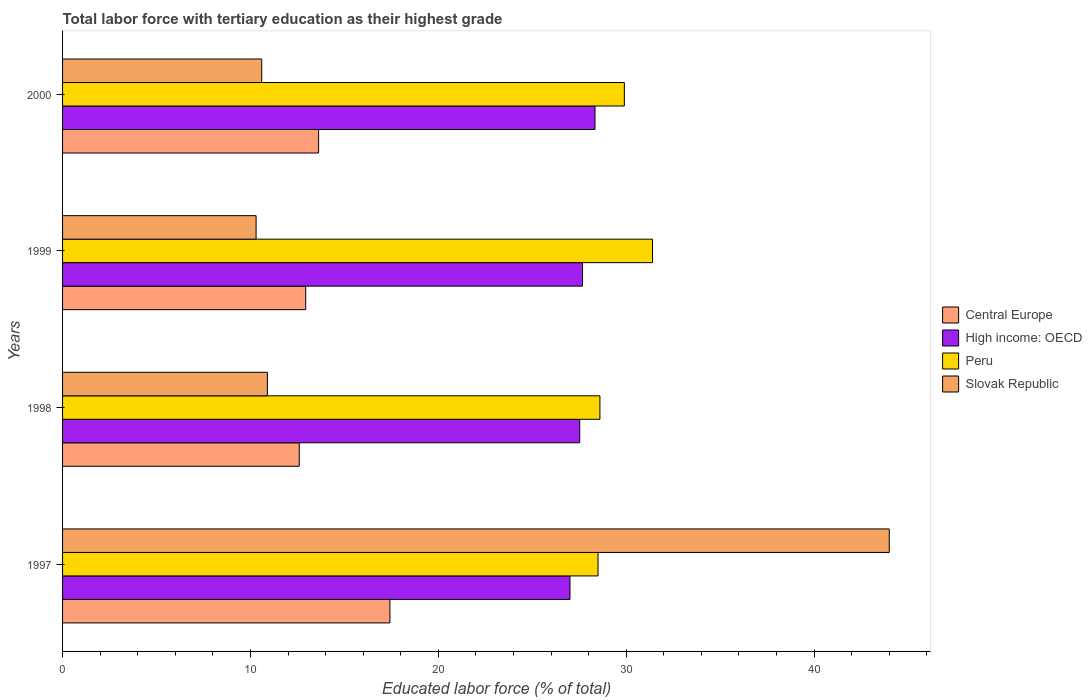How many bars are there on the 1st tick from the top?
Ensure brevity in your answer.  4. In how many cases, is the number of bars for a given year not equal to the number of legend labels?
Your response must be concise. 0. What is the percentage of male labor force with tertiary education in Central Europe in 1998?
Provide a succinct answer. 12.6. Across all years, what is the minimum percentage of male labor force with tertiary education in High income: OECD?
Ensure brevity in your answer.  27.01. In which year was the percentage of male labor force with tertiary education in Peru maximum?
Give a very brief answer. 1999. In which year was the percentage of male labor force with tertiary education in High income: OECD minimum?
Ensure brevity in your answer.  1997. What is the total percentage of male labor force with tertiary education in Central Europe in the graph?
Keep it short and to the point. 56.59. What is the difference between the percentage of male labor force with tertiary education in Peru in 1997 and that in 1999?
Your answer should be compact. -2.9. What is the difference between the percentage of male labor force with tertiary education in Slovak Republic in 2000 and the percentage of male labor force with tertiary education in High income: OECD in 1997?
Offer a very short reply. -16.41. What is the average percentage of male labor force with tertiary education in High income: OECD per year?
Ensure brevity in your answer.  27.64. In the year 1999, what is the difference between the percentage of male labor force with tertiary education in Peru and percentage of male labor force with tertiary education in Central Europe?
Your response must be concise. 18.46. What is the ratio of the percentage of male labor force with tertiary education in High income: OECD in 1998 to that in 1999?
Keep it short and to the point. 0.99. What is the difference between the highest and the lowest percentage of male labor force with tertiary education in High income: OECD?
Your answer should be compact. 1.33. In how many years, is the percentage of male labor force with tertiary education in High income: OECD greater than the average percentage of male labor force with tertiary education in High income: OECD taken over all years?
Make the answer very short. 2. Is the sum of the percentage of male labor force with tertiary education in Central Europe in 1997 and 1999 greater than the maximum percentage of male labor force with tertiary education in Slovak Republic across all years?
Provide a succinct answer. No. Is it the case that in every year, the sum of the percentage of male labor force with tertiary education in Peru and percentage of male labor force with tertiary education in High income: OECD is greater than the sum of percentage of male labor force with tertiary education in Central Europe and percentage of male labor force with tertiary education in Slovak Republic?
Make the answer very short. Yes. What does the 4th bar from the top in 1998 represents?
Offer a terse response. Central Europe. How many years are there in the graph?
Provide a short and direct response. 4. What is the difference between two consecutive major ticks on the X-axis?
Give a very brief answer. 10. Does the graph contain any zero values?
Your answer should be very brief. No. Does the graph contain grids?
Make the answer very short. No. Where does the legend appear in the graph?
Provide a succinct answer. Center right. How many legend labels are there?
Your answer should be compact. 4. How are the legend labels stacked?
Keep it short and to the point. Vertical. What is the title of the graph?
Your answer should be compact. Total labor force with tertiary education as their highest grade. What is the label or title of the X-axis?
Your answer should be compact. Educated labor force (% of total). What is the Educated labor force (% of total) in Central Europe in 1997?
Ensure brevity in your answer.  17.42. What is the Educated labor force (% of total) of High income: OECD in 1997?
Offer a terse response. 27.01. What is the Educated labor force (% of total) of Peru in 1997?
Offer a very short reply. 28.5. What is the Educated labor force (% of total) of Slovak Republic in 1997?
Provide a succinct answer. 44. What is the Educated labor force (% of total) in Central Europe in 1998?
Give a very brief answer. 12.6. What is the Educated labor force (% of total) of High income: OECD in 1998?
Provide a succinct answer. 27.52. What is the Educated labor force (% of total) in Peru in 1998?
Your response must be concise. 28.6. What is the Educated labor force (% of total) of Slovak Republic in 1998?
Offer a very short reply. 10.9. What is the Educated labor force (% of total) of Central Europe in 1999?
Your answer should be compact. 12.94. What is the Educated labor force (% of total) of High income: OECD in 1999?
Your response must be concise. 27.67. What is the Educated labor force (% of total) in Peru in 1999?
Make the answer very short. 31.4. What is the Educated labor force (% of total) of Slovak Republic in 1999?
Offer a very short reply. 10.3. What is the Educated labor force (% of total) in Central Europe in 2000?
Offer a very short reply. 13.63. What is the Educated labor force (% of total) of High income: OECD in 2000?
Provide a short and direct response. 28.34. What is the Educated labor force (% of total) of Peru in 2000?
Provide a short and direct response. 29.9. What is the Educated labor force (% of total) in Slovak Republic in 2000?
Offer a terse response. 10.6. Across all years, what is the maximum Educated labor force (% of total) of Central Europe?
Your answer should be very brief. 17.42. Across all years, what is the maximum Educated labor force (% of total) of High income: OECD?
Provide a short and direct response. 28.34. Across all years, what is the maximum Educated labor force (% of total) in Peru?
Your answer should be very brief. 31.4. Across all years, what is the minimum Educated labor force (% of total) in Central Europe?
Offer a very short reply. 12.6. Across all years, what is the minimum Educated labor force (% of total) in High income: OECD?
Your response must be concise. 27.01. Across all years, what is the minimum Educated labor force (% of total) of Peru?
Your response must be concise. 28.5. Across all years, what is the minimum Educated labor force (% of total) of Slovak Republic?
Offer a terse response. 10.3. What is the total Educated labor force (% of total) in Central Europe in the graph?
Provide a succinct answer. 56.59. What is the total Educated labor force (% of total) of High income: OECD in the graph?
Your answer should be very brief. 110.54. What is the total Educated labor force (% of total) in Peru in the graph?
Offer a very short reply. 118.4. What is the total Educated labor force (% of total) of Slovak Republic in the graph?
Offer a terse response. 75.8. What is the difference between the Educated labor force (% of total) of Central Europe in 1997 and that in 1998?
Your answer should be very brief. 4.83. What is the difference between the Educated labor force (% of total) in High income: OECD in 1997 and that in 1998?
Provide a short and direct response. -0.52. What is the difference between the Educated labor force (% of total) in Slovak Republic in 1997 and that in 1998?
Your answer should be very brief. 33.1. What is the difference between the Educated labor force (% of total) in Central Europe in 1997 and that in 1999?
Your answer should be very brief. 4.48. What is the difference between the Educated labor force (% of total) of High income: OECD in 1997 and that in 1999?
Keep it short and to the point. -0.67. What is the difference between the Educated labor force (% of total) in Peru in 1997 and that in 1999?
Provide a short and direct response. -2.9. What is the difference between the Educated labor force (% of total) in Slovak Republic in 1997 and that in 1999?
Provide a short and direct response. 33.7. What is the difference between the Educated labor force (% of total) in Central Europe in 1997 and that in 2000?
Make the answer very short. 3.8. What is the difference between the Educated labor force (% of total) of High income: OECD in 1997 and that in 2000?
Provide a succinct answer. -1.33. What is the difference between the Educated labor force (% of total) in Peru in 1997 and that in 2000?
Your answer should be very brief. -1.4. What is the difference between the Educated labor force (% of total) of Slovak Republic in 1997 and that in 2000?
Provide a succinct answer. 33.4. What is the difference between the Educated labor force (% of total) in Central Europe in 1998 and that in 1999?
Provide a short and direct response. -0.34. What is the difference between the Educated labor force (% of total) in High income: OECD in 1998 and that in 1999?
Offer a terse response. -0.15. What is the difference between the Educated labor force (% of total) in Central Europe in 1998 and that in 2000?
Make the answer very short. -1.03. What is the difference between the Educated labor force (% of total) of High income: OECD in 1998 and that in 2000?
Provide a succinct answer. -0.81. What is the difference between the Educated labor force (% of total) of Peru in 1998 and that in 2000?
Offer a terse response. -1.3. What is the difference between the Educated labor force (% of total) of Central Europe in 1999 and that in 2000?
Your response must be concise. -0.69. What is the difference between the Educated labor force (% of total) of High income: OECD in 1999 and that in 2000?
Provide a short and direct response. -0.67. What is the difference between the Educated labor force (% of total) of Slovak Republic in 1999 and that in 2000?
Your answer should be very brief. -0.3. What is the difference between the Educated labor force (% of total) of Central Europe in 1997 and the Educated labor force (% of total) of High income: OECD in 1998?
Keep it short and to the point. -10.1. What is the difference between the Educated labor force (% of total) of Central Europe in 1997 and the Educated labor force (% of total) of Peru in 1998?
Provide a short and direct response. -11.18. What is the difference between the Educated labor force (% of total) of Central Europe in 1997 and the Educated labor force (% of total) of Slovak Republic in 1998?
Offer a very short reply. 6.52. What is the difference between the Educated labor force (% of total) of High income: OECD in 1997 and the Educated labor force (% of total) of Peru in 1998?
Give a very brief answer. -1.59. What is the difference between the Educated labor force (% of total) of High income: OECD in 1997 and the Educated labor force (% of total) of Slovak Republic in 1998?
Provide a succinct answer. 16.11. What is the difference between the Educated labor force (% of total) of Central Europe in 1997 and the Educated labor force (% of total) of High income: OECD in 1999?
Make the answer very short. -10.25. What is the difference between the Educated labor force (% of total) in Central Europe in 1997 and the Educated labor force (% of total) in Peru in 1999?
Provide a short and direct response. -13.98. What is the difference between the Educated labor force (% of total) in Central Europe in 1997 and the Educated labor force (% of total) in Slovak Republic in 1999?
Your response must be concise. 7.12. What is the difference between the Educated labor force (% of total) in High income: OECD in 1997 and the Educated labor force (% of total) in Peru in 1999?
Keep it short and to the point. -4.39. What is the difference between the Educated labor force (% of total) of High income: OECD in 1997 and the Educated labor force (% of total) of Slovak Republic in 1999?
Ensure brevity in your answer.  16.71. What is the difference between the Educated labor force (% of total) of Central Europe in 1997 and the Educated labor force (% of total) of High income: OECD in 2000?
Give a very brief answer. -10.92. What is the difference between the Educated labor force (% of total) in Central Europe in 1997 and the Educated labor force (% of total) in Peru in 2000?
Ensure brevity in your answer.  -12.48. What is the difference between the Educated labor force (% of total) of Central Europe in 1997 and the Educated labor force (% of total) of Slovak Republic in 2000?
Give a very brief answer. 6.82. What is the difference between the Educated labor force (% of total) in High income: OECD in 1997 and the Educated labor force (% of total) in Peru in 2000?
Offer a terse response. -2.89. What is the difference between the Educated labor force (% of total) of High income: OECD in 1997 and the Educated labor force (% of total) of Slovak Republic in 2000?
Make the answer very short. 16.41. What is the difference between the Educated labor force (% of total) in Central Europe in 1998 and the Educated labor force (% of total) in High income: OECD in 1999?
Provide a short and direct response. -15.08. What is the difference between the Educated labor force (% of total) of Central Europe in 1998 and the Educated labor force (% of total) of Peru in 1999?
Ensure brevity in your answer.  -18.8. What is the difference between the Educated labor force (% of total) of Central Europe in 1998 and the Educated labor force (% of total) of Slovak Republic in 1999?
Keep it short and to the point. 2.3. What is the difference between the Educated labor force (% of total) in High income: OECD in 1998 and the Educated labor force (% of total) in Peru in 1999?
Your response must be concise. -3.88. What is the difference between the Educated labor force (% of total) in High income: OECD in 1998 and the Educated labor force (% of total) in Slovak Republic in 1999?
Your answer should be compact. 17.22. What is the difference between the Educated labor force (% of total) of Central Europe in 1998 and the Educated labor force (% of total) of High income: OECD in 2000?
Your answer should be compact. -15.74. What is the difference between the Educated labor force (% of total) of Central Europe in 1998 and the Educated labor force (% of total) of Peru in 2000?
Ensure brevity in your answer.  -17.3. What is the difference between the Educated labor force (% of total) of Central Europe in 1998 and the Educated labor force (% of total) of Slovak Republic in 2000?
Provide a short and direct response. 2. What is the difference between the Educated labor force (% of total) in High income: OECD in 1998 and the Educated labor force (% of total) in Peru in 2000?
Provide a succinct answer. -2.38. What is the difference between the Educated labor force (% of total) in High income: OECD in 1998 and the Educated labor force (% of total) in Slovak Republic in 2000?
Offer a very short reply. 16.92. What is the difference between the Educated labor force (% of total) of Central Europe in 1999 and the Educated labor force (% of total) of High income: OECD in 2000?
Your response must be concise. -15.4. What is the difference between the Educated labor force (% of total) in Central Europe in 1999 and the Educated labor force (% of total) in Peru in 2000?
Ensure brevity in your answer.  -16.96. What is the difference between the Educated labor force (% of total) in Central Europe in 1999 and the Educated labor force (% of total) in Slovak Republic in 2000?
Your response must be concise. 2.34. What is the difference between the Educated labor force (% of total) of High income: OECD in 1999 and the Educated labor force (% of total) of Peru in 2000?
Provide a short and direct response. -2.23. What is the difference between the Educated labor force (% of total) of High income: OECD in 1999 and the Educated labor force (% of total) of Slovak Republic in 2000?
Offer a very short reply. 17.07. What is the difference between the Educated labor force (% of total) of Peru in 1999 and the Educated labor force (% of total) of Slovak Republic in 2000?
Keep it short and to the point. 20.8. What is the average Educated labor force (% of total) in Central Europe per year?
Your answer should be very brief. 14.15. What is the average Educated labor force (% of total) in High income: OECD per year?
Offer a terse response. 27.64. What is the average Educated labor force (% of total) of Peru per year?
Offer a very short reply. 29.6. What is the average Educated labor force (% of total) of Slovak Republic per year?
Ensure brevity in your answer.  18.95. In the year 1997, what is the difference between the Educated labor force (% of total) in Central Europe and Educated labor force (% of total) in High income: OECD?
Your answer should be compact. -9.58. In the year 1997, what is the difference between the Educated labor force (% of total) of Central Europe and Educated labor force (% of total) of Peru?
Your response must be concise. -11.08. In the year 1997, what is the difference between the Educated labor force (% of total) of Central Europe and Educated labor force (% of total) of Slovak Republic?
Offer a very short reply. -26.58. In the year 1997, what is the difference between the Educated labor force (% of total) of High income: OECD and Educated labor force (% of total) of Peru?
Your answer should be very brief. -1.49. In the year 1997, what is the difference between the Educated labor force (% of total) in High income: OECD and Educated labor force (% of total) in Slovak Republic?
Provide a short and direct response. -16.99. In the year 1997, what is the difference between the Educated labor force (% of total) in Peru and Educated labor force (% of total) in Slovak Republic?
Your answer should be very brief. -15.5. In the year 1998, what is the difference between the Educated labor force (% of total) in Central Europe and Educated labor force (% of total) in High income: OECD?
Provide a succinct answer. -14.93. In the year 1998, what is the difference between the Educated labor force (% of total) in Central Europe and Educated labor force (% of total) in Peru?
Your response must be concise. -16. In the year 1998, what is the difference between the Educated labor force (% of total) of Central Europe and Educated labor force (% of total) of Slovak Republic?
Provide a short and direct response. 1.7. In the year 1998, what is the difference between the Educated labor force (% of total) in High income: OECD and Educated labor force (% of total) in Peru?
Your response must be concise. -1.08. In the year 1998, what is the difference between the Educated labor force (% of total) of High income: OECD and Educated labor force (% of total) of Slovak Republic?
Provide a short and direct response. 16.62. In the year 1998, what is the difference between the Educated labor force (% of total) of Peru and Educated labor force (% of total) of Slovak Republic?
Provide a succinct answer. 17.7. In the year 1999, what is the difference between the Educated labor force (% of total) of Central Europe and Educated labor force (% of total) of High income: OECD?
Offer a very short reply. -14.73. In the year 1999, what is the difference between the Educated labor force (% of total) in Central Europe and Educated labor force (% of total) in Peru?
Your answer should be compact. -18.46. In the year 1999, what is the difference between the Educated labor force (% of total) in Central Europe and Educated labor force (% of total) in Slovak Republic?
Make the answer very short. 2.64. In the year 1999, what is the difference between the Educated labor force (% of total) of High income: OECD and Educated labor force (% of total) of Peru?
Ensure brevity in your answer.  -3.73. In the year 1999, what is the difference between the Educated labor force (% of total) of High income: OECD and Educated labor force (% of total) of Slovak Republic?
Keep it short and to the point. 17.37. In the year 1999, what is the difference between the Educated labor force (% of total) of Peru and Educated labor force (% of total) of Slovak Republic?
Make the answer very short. 21.1. In the year 2000, what is the difference between the Educated labor force (% of total) of Central Europe and Educated labor force (% of total) of High income: OECD?
Your response must be concise. -14.71. In the year 2000, what is the difference between the Educated labor force (% of total) of Central Europe and Educated labor force (% of total) of Peru?
Provide a short and direct response. -16.27. In the year 2000, what is the difference between the Educated labor force (% of total) in Central Europe and Educated labor force (% of total) in Slovak Republic?
Your answer should be compact. 3.03. In the year 2000, what is the difference between the Educated labor force (% of total) of High income: OECD and Educated labor force (% of total) of Peru?
Provide a succinct answer. -1.56. In the year 2000, what is the difference between the Educated labor force (% of total) in High income: OECD and Educated labor force (% of total) in Slovak Republic?
Provide a succinct answer. 17.74. In the year 2000, what is the difference between the Educated labor force (% of total) of Peru and Educated labor force (% of total) of Slovak Republic?
Your answer should be compact. 19.3. What is the ratio of the Educated labor force (% of total) of Central Europe in 1997 to that in 1998?
Offer a terse response. 1.38. What is the ratio of the Educated labor force (% of total) of High income: OECD in 1997 to that in 1998?
Your answer should be very brief. 0.98. What is the ratio of the Educated labor force (% of total) in Slovak Republic in 1997 to that in 1998?
Provide a short and direct response. 4.04. What is the ratio of the Educated labor force (% of total) in Central Europe in 1997 to that in 1999?
Keep it short and to the point. 1.35. What is the ratio of the Educated labor force (% of total) of High income: OECD in 1997 to that in 1999?
Provide a short and direct response. 0.98. What is the ratio of the Educated labor force (% of total) in Peru in 1997 to that in 1999?
Your answer should be very brief. 0.91. What is the ratio of the Educated labor force (% of total) in Slovak Republic in 1997 to that in 1999?
Keep it short and to the point. 4.27. What is the ratio of the Educated labor force (% of total) in Central Europe in 1997 to that in 2000?
Offer a very short reply. 1.28. What is the ratio of the Educated labor force (% of total) of High income: OECD in 1997 to that in 2000?
Your answer should be very brief. 0.95. What is the ratio of the Educated labor force (% of total) of Peru in 1997 to that in 2000?
Give a very brief answer. 0.95. What is the ratio of the Educated labor force (% of total) of Slovak Republic in 1997 to that in 2000?
Offer a terse response. 4.15. What is the ratio of the Educated labor force (% of total) of Central Europe in 1998 to that in 1999?
Ensure brevity in your answer.  0.97. What is the ratio of the Educated labor force (% of total) of High income: OECD in 1998 to that in 1999?
Your answer should be very brief. 0.99. What is the ratio of the Educated labor force (% of total) of Peru in 1998 to that in 1999?
Your answer should be compact. 0.91. What is the ratio of the Educated labor force (% of total) of Slovak Republic in 1998 to that in 1999?
Make the answer very short. 1.06. What is the ratio of the Educated labor force (% of total) in Central Europe in 1998 to that in 2000?
Provide a short and direct response. 0.92. What is the ratio of the Educated labor force (% of total) of High income: OECD in 1998 to that in 2000?
Ensure brevity in your answer.  0.97. What is the ratio of the Educated labor force (% of total) of Peru in 1998 to that in 2000?
Provide a short and direct response. 0.96. What is the ratio of the Educated labor force (% of total) in Slovak Republic in 1998 to that in 2000?
Offer a terse response. 1.03. What is the ratio of the Educated labor force (% of total) of Central Europe in 1999 to that in 2000?
Provide a succinct answer. 0.95. What is the ratio of the Educated labor force (% of total) of High income: OECD in 1999 to that in 2000?
Keep it short and to the point. 0.98. What is the ratio of the Educated labor force (% of total) of Peru in 1999 to that in 2000?
Keep it short and to the point. 1.05. What is the ratio of the Educated labor force (% of total) in Slovak Republic in 1999 to that in 2000?
Your answer should be very brief. 0.97. What is the difference between the highest and the second highest Educated labor force (% of total) in Central Europe?
Offer a very short reply. 3.8. What is the difference between the highest and the second highest Educated labor force (% of total) of High income: OECD?
Your answer should be very brief. 0.67. What is the difference between the highest and the second highest Educated labor force (% of total) in Peru?
Your answer should be very brief. 1.5. What is the difference between the highest and the second highest Educated labor force (% of total) in Slovak Republic?
Keep it short and to the point. 33.1. What is the difference between the highest and the lowest Educated labor force (% of total) in Central Europe?
Your answer should be compact. 4.83. What is the difference between the highest and the lowest Educated labor force (% of total) in High income: OECD?
Your response must be concise. 1.33. What is the difference between the highest and the lowest Educated labor force (% of total) in Slovak Republic?
Your answer should be very brief. 33.7. 